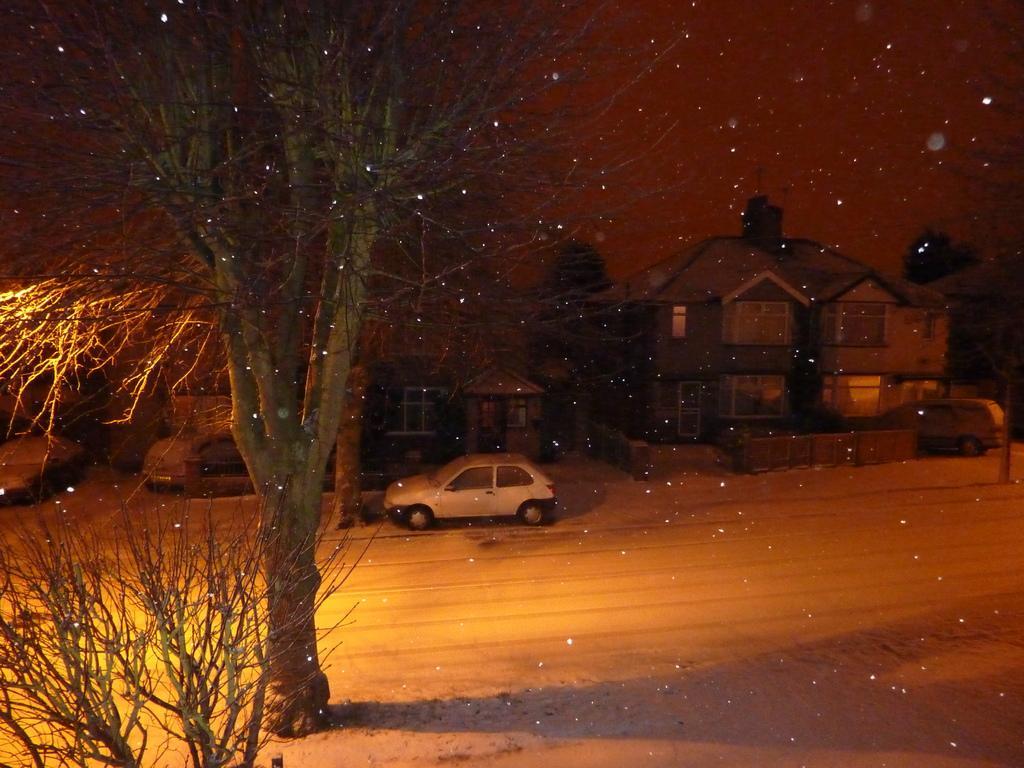Describe this image in one or two sentences. In this picture there are buildings and there are vehicles and there are trees. At the top there is sky. At the bottom there is a road. This picture is an edited picture. 